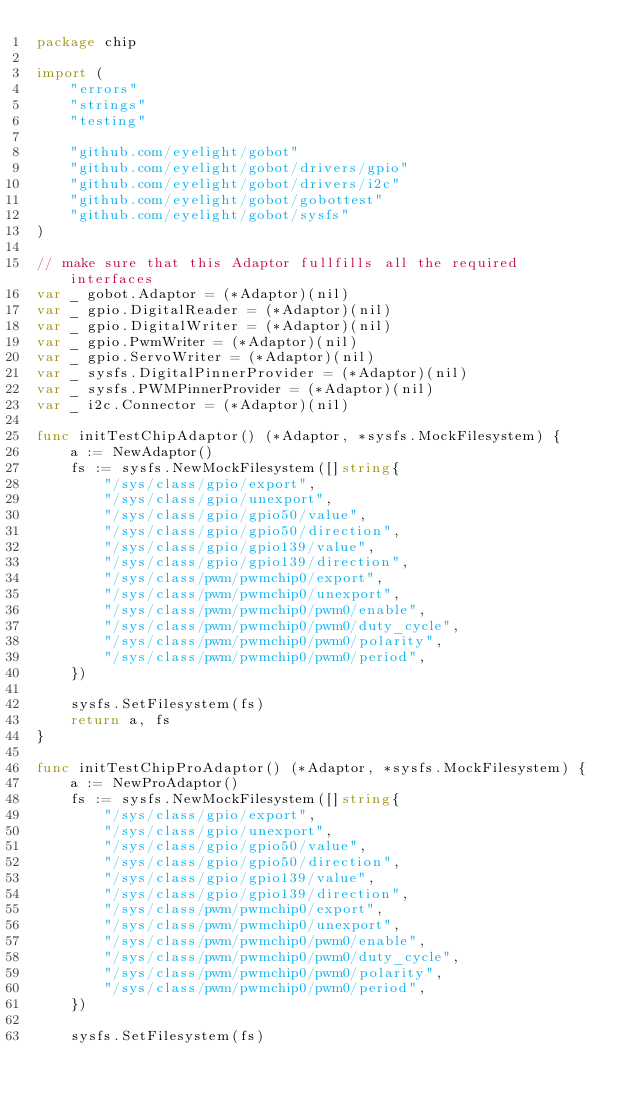<code> <loc_0><loc_0><loc_500><loc_500><_Go_>package chip

import (
	"errors"
	"strings"
	"testing"

	"github.com/eyelight/gobot"
	"github.com/eyelight/gobot/drivers/gpio"
	"github.com/eyelight/gobot/drivers/i2c"
	"github.com/eyelight/gobot/gobottest"
	"github.com/eyelight/gobot/sysfs"
)

// make sure that this Adaptor fullfills all the required interfaces
var _ gobot.Adaptor = (*Adaptor)(nil)
var _ gpio.DigitalReader = (*Adaptor)(nil)
var _ gpio.DigitalWriter = (*Adaptor)(nil)
var _ gpio.PwmWriter = (*Adaptor)(nil)
var _ gpio.ServoWriter = (*Adaptor)(nil)
var _ sysfs.DigitalPinnerProvider = (*Adaptor)(nil)
var _ sysfs.PWMPinnerProvider = (*Adaptor)(nil)
var _ i2c.Connector = (*Adaptor)(nil)

func initTestChipAdaptor() (*Adaptor, *sysfs.MockFilesystem) {
	a := NewAdaptor()
	fs := sysfs.NewMockFilesystem([]string{
		"/sys/class/gpio/export",
		"/sys/class/gpio/unexport",
		"/sys/class/gpio/gpio50/value",
		"/sys/class/gpio/gpio50/direction",
		"/sys/class/gpio/gpio139/value",
		"/sys/class/gpio/gpio139/direction",
		"/sys/class/pwm/pwmchip0/export",
		"/sys/class/pwm/pwmchip0/unexport",
		"/sys/class/pwm/pwmchip0/pwm0/enable",
		"/sys/class/pwm/pwmchip0/pwm0/duty_cycle",
		"/sys/class/pwm/pwmchip0/pwm0/polarity",
		"/sys/class/pwm/pwmchip0/pwm0/period",
	})

	sysfs.SetFilesystem(fs)
	return a, fs
}

func initTestChipProAdaptor() (*Adaptor, *sysfs.MockFilesystem) {
	a := NewProAdaptor()
	fs := sysfs.NewMockFilesystem([]string{
		"/sys/class/gpio/export",
		"/sys/class/gpio/unexport",
		"/sys/class/gpio/gpio50/value",
		"/sys/class/gpio/gpio50/direction",
		"/sys/class/gpio/gpio139/value",
		"/sys/class/gpio/gpio139/direction",
		"/sys/class/pwm/pwmchip0/export",
		"/sys/class/pwm/pwmchip0/unexport",
		"/sys/class/pwm/pwmchip0/pwm0/enable",
		"/sys/class/pwm/pwmchip0/pwm0/duty_cycle",
		"/sys/class/pwm/pwmchip0/pwm0/polarity",
		"/sys/class/pwm/pwmchip0/pwm0/period",
	})

	sysfs.SetFilesystem(fs)</code> 